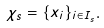<formula> <loc_0><loc_0><loc_500><loc_500>\chi _ { s } = \{ x _ { i } \} _ { i \in I _ { s } } .</formula> 